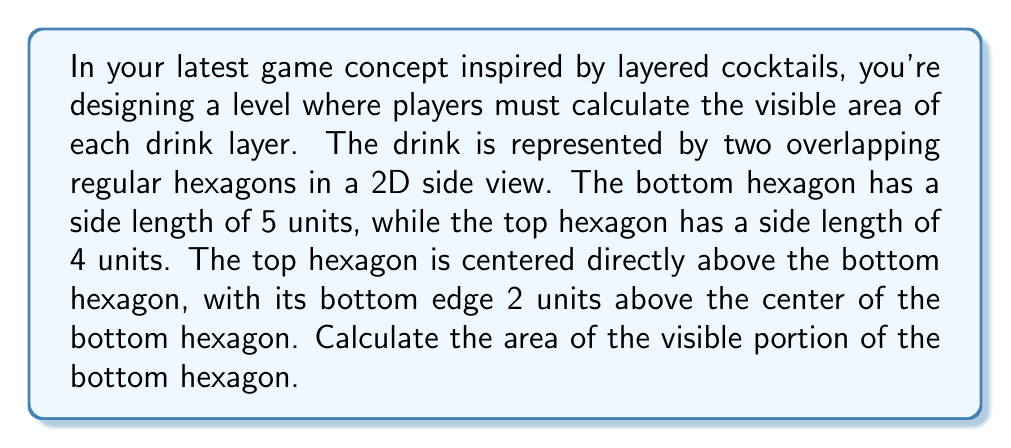Help me with this question. Let's approach this step-by-step:

1) First, we need to calculate the area of each hexagon:
   Area of a regular hexagon = $\frac{3\sqrt{3}}{2}s^2$, where $s$ is the side length.

   Bottom hexagon: $A_1 = \frac{3\sqrt{3}}{2}(5^2) = \frac{75\sqrt{3}}{2}$ square units
   Top hexagon: $A_2 = \frac{3\sqrt{3}}{2}(4^2) = 24\sqrt{3}$ square units

2) Now, we need to find the area of overlap. The overlap forms a complex shape, but we can calculate it by subtracting the non-overlapping part of the top hexagon from its total area.

3) To find the non-overlapping part, we need to calculate the height of the top hexagon that's above the bottom hexagon:
   Height of a regular hexagon = $h = s\sqrt{3}$
   For the top hexagon: $h_2 = 4\sqrt{3}$ units

   The distance from the center of the bottom hexagon to the bottom of the top hexagon is 2 units.
   So, the height of the non-overlapping part is: $4\sqrt{3} - 2 = 2(2\sqrt{3} - 1)$ units

4) The ratio of this height to the total height gives us the fraction of the top hexagon that doesn't overlap:
   Fraction = $\frac{2(2\sqrt{3} - 1)}{4\sqrt{3}} = 1 - \frac{1}{2\sqrt{3}}$

5) Therefore, the non-overlapping area of the top hexagon is:
   $24\sqrt{3} * (1 - \frac{1}{2\sqrt{3}}) = 24\sqrt{3} - 12$ square units

6) The overlap area is then:
   $24\sqrt{3} - (24\sqrt{3} - 12) = 12$ square units

7) Finally, the visible area of the bottom hexagon is its total area minus the overlap:
   $\frac{75\sqrt{3}}{2} - 12 = \frac{75\sqrt{3}}{2} - 12$ square units
Answer: $\frac{75\sqrt{3}}{2} - 12$ square units 